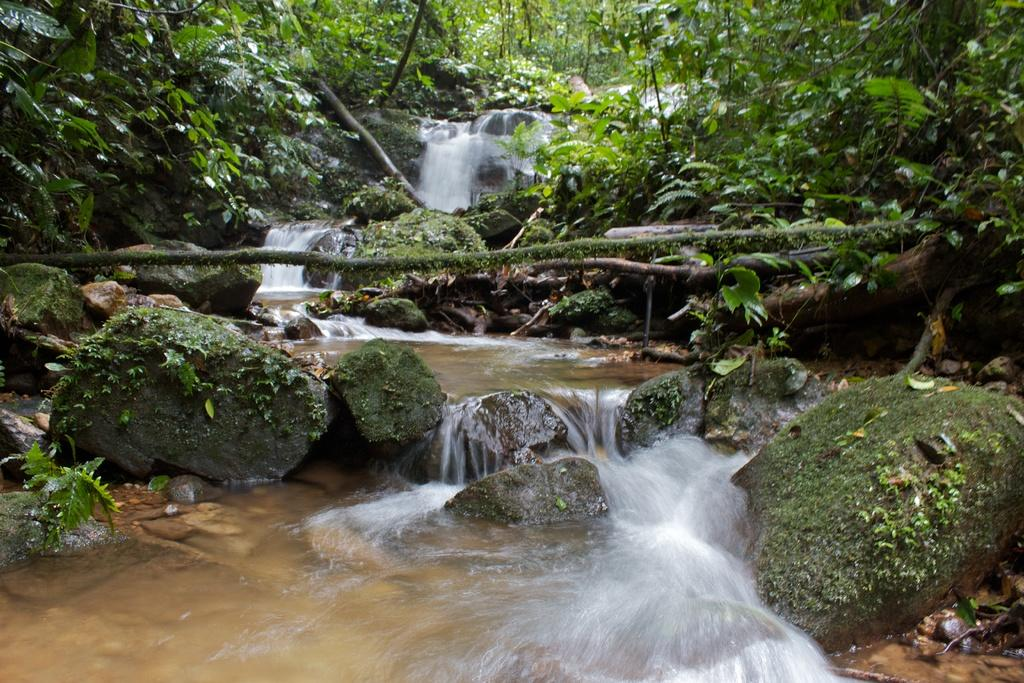What type of vegetation can be seen in the image? There are leaves and branches in the image. What other natural elements are present in the image? There are rocks in the image. What can be seen in the background of the image? There is water visible in the image. What type of agreement can be seen between the leaves and rocks in the image? There is no agreement between the leaves and rocks in the image, as they are inanimate objects and do not have the ability to form agreements. 